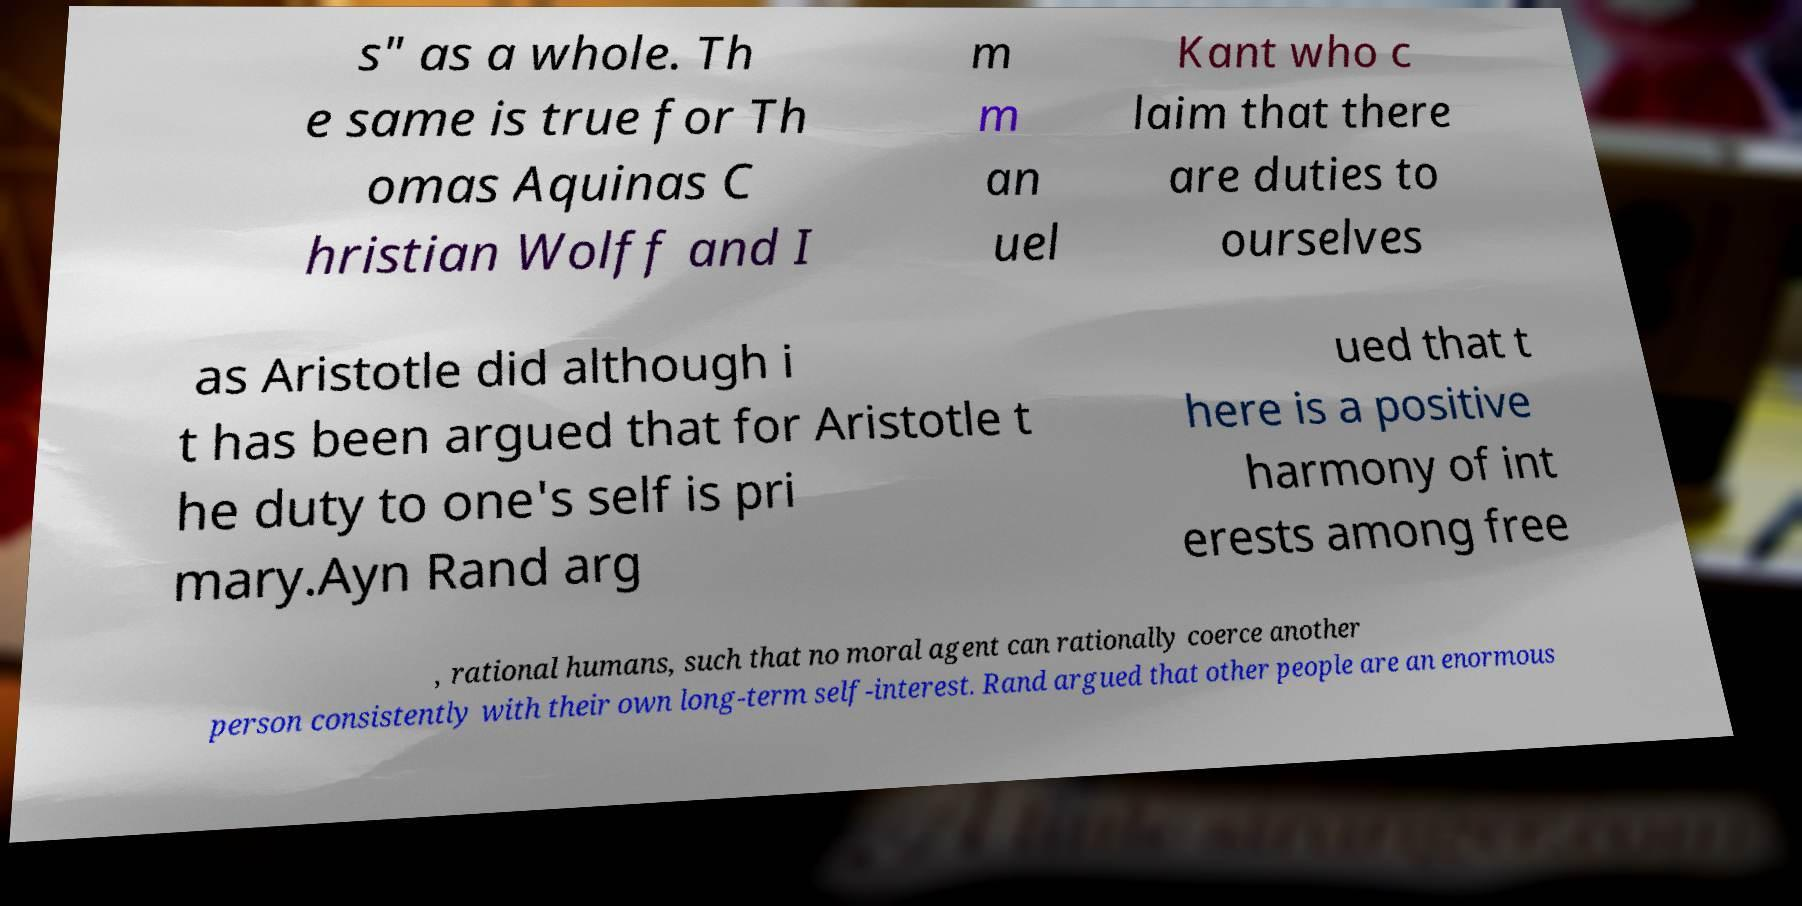What messages or text are displayed in this image? I need them in a readable, typed format. s" as a whole. Th e same is true for Th omas Aquinas C hristian Wolff and I m m an uel Kant who c laim that there are duties to ourselves as Aristotle did although i t has been argued that for Aristotle t he duty to one's self is pri mary.Ayn Rand arg ued that t here is a positive harmony of int erests among free , rational humans, such that no moral agent can rationally coerce another person consistently with their own long-term self-interest. Rand argued that other people are an enormous 